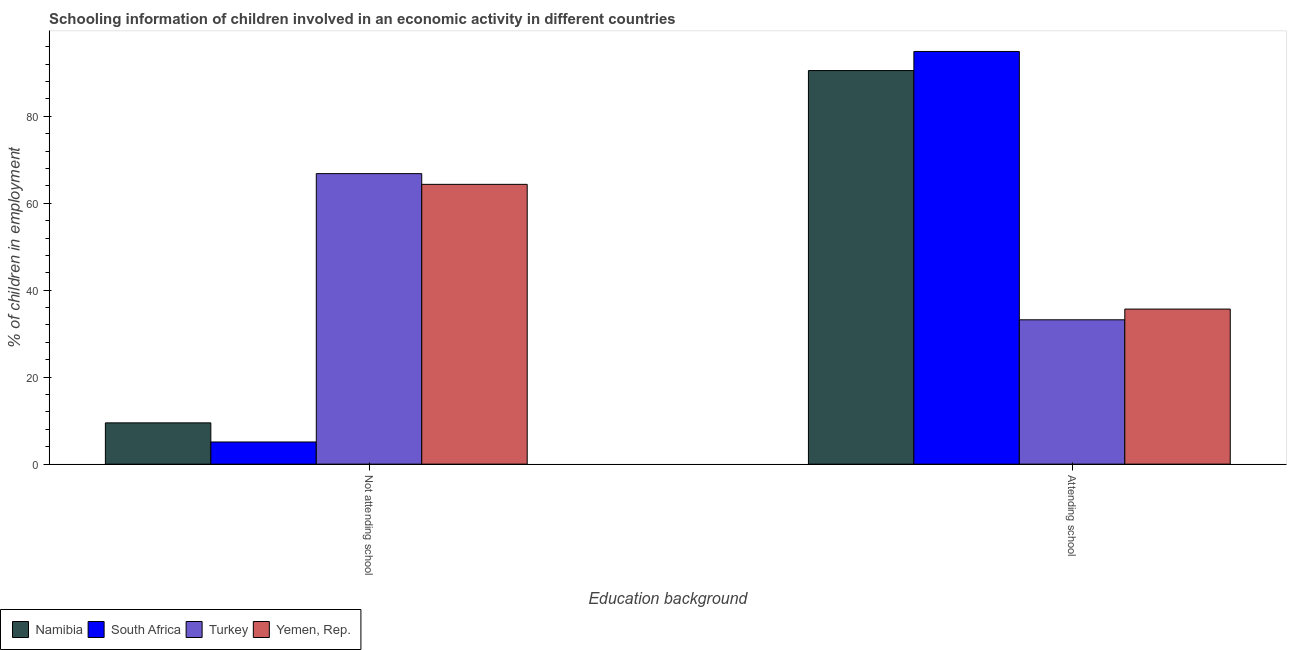How many different coloured bars are there?
Make the answer very short. 4. How many groups of bars are there?
Provide a succinct answer. 2. How many bars are there on the 1st tick from the left?
Ensure brevity in your answer.  4. What is the label of the 1st group of bars from the left?
Give a very brief answer. Not attending school. Across all countries, what is the maximum percentage of employed children who are attending school?
Keep it short and to the point. 94.9. In which country was the percentage of employed children who are attending school maximum?
Keep it short and to the point. South Africa. In which country was the percentage of employed children who are attending school minimum?
Offer a terse response. Turkey. What is the total percentage of employed children who are not attending school in the graph?
Your response must be concise. 145.74. What is the difference between the percentage of employed children who are attending school in Turkey and that in South Africa?
Keep it short and to the point. -61.71. What is the difference between the percentage of employed children who are not attending school in Yemen, Rep. and the percentage of employed children who are attending school in Namibia?
Provide a succinct answer. -26.17. What is the average percentage of employed children who are not attending school per country?
Offer a very short reply. 36.43. What is the difference between the percentage of employed children who are not attending school and percentage of employed children who are attending school in Yemen, Rep.?
Offer a terse response. 28.68. In how many countries, is the percentage of employed children who are attending school greater than 28 %?
Provide a succinct answer. 4. What is the ratio of the percentage of employed children who are attending school in Namibia to that in Yemen, Rep.?
Provide a short and direct response. 2.54. In how many countries, is the percentage of employed children who are not attending school greater than the average percentage of employed children who are not attending school taken over all countries?
Your response must be concise. 2. What does the 3rd bar from the right in Attending school represents?
Your response must be concise. South Africa. How many bars are there?
Provide a short and direct response. 8. How many countries are there in the graph?
Your answer should be compact. 4. What is the difference between two consecutive major ticks on the Y-axis?
Provide a succinct answer. 20. Are the values on the major ticks of Y-axis written in scientific E-notation?
Offer a terse response. No. Does the graph contain any zero values?
Your answer should be very brief. No. Does the graph contain grids?
Keep it short and to the point. No. How many legend labels are there?
Make the answer very short. 4. What is the title of the graph?
Offer a terse response. Schooling information of children involved in an economic activity in different countries. What is the label or title of the X-axis?
Ensure brevity in your answer.  Education background. What is the label or title of the Y-axis?
Your answer should be compact. % of children in employment. What is the % of children in employment in Namibia in Not attending school?
Make the answer very short. 9.49. What is the % of children in employment in Turkey in Not attending school?
Offer a very short reply. 66.81. What is the % of children in employment in Yemen, Rep. in Not attending school?
Your answer should be compact. 64.34. What is the % of children in employment in Namibia in Attending school?
Offer a terse response. 90.51. What is the % of children in employment of South Africa in Attending school?
Make the answer very short. 94.9. What is the % of children in employment of Turkey in Attending school?
Make the answer very short. 33.19. What is the % of children in employment in Yemen, Rep. in Attending school?
Ensure brevity in your answer.  35.66. Across all Education background, what is the maximum % of children in employment in Namibia?
Make the answer very short. 90.51. Across all Education background, what is the maximum % of children in employment in South Africa?
Provide a succinct answer. 94.9. Across all Education background, what is the maximum % of children in employment in Turkey?
Provide a short and direct response. 66.81. Across all Education background, what is the maximum % of children in employment in Yemen, Rep.?
Offer a terse response. 64.34. Across all Education background, what is the minimum % of children in employment in Namibia?
Provide a short and direct response. 9.49. Across all Education background, what is the minimum % of children in employment in South Africa?
Make the answer very short. 5.1. Across all Education background, what is the minimum % of children in employment in Turkey?
Give a very brief answer. 33.19. Across all Education background, what is the minimum % of children in employment in Yemen, Rep.?
Offer a very short reply. 35.66. What is the total % of children in employment of Namibia in the graph?
Offer a very short reply. 100. What is the total % of children in employment in Turkey in the graph?
Your response must be concise. 100. What is the difference between the % of children in employment of Namibia in Not attending school and that in Attending school?
Your response must be concise. -81.01. What is the difference between the % of children in employment of South Africa in Not attending school and that in Attending school?
Make the answer very short. -89.8. What is the difference between the % of children in employment in Turkey in Not attending school and that in Attending school?
Your answer should be compact. 33.61. What is the difference between the % of children in employment in Yemen, Rep. in Not attending school and that in Attending school?
Keep it short and to the point. 28.68. What is the difference between the % of children in employment of Namibia in Not attending school and the % of children in employment of South Africa in Attending school?
Keep it short and to the point. -85.41. What is the difference between the % of children in employment in Namibia in Not attending school and the % of children in employment in Turkey in Attending school?
Ensure brevity in your answer.  -23.7. What is the difference between the % of children in employment in Namibia in Not attending school and the % of children in employment in Yemen, Rep. in Attending school?
Provide a short and direct response. -26.17. What is the difference between the % of children in employment in South Africa in Not attending school and the % of children in employment in Turkey in Attending school?
Make the answer very short. -28.09. What is the difference between the % of children in employment in South Africa in Not attending school and the % of children in employment in Yemen, Rep. in Attending school?
Your answer should be very brief. -30.56. What is the difference between the % of children in employment in Turkey in Not attending school and the % of children in employment in Yemen, Rep. in Attending school?
Offer a very short reply. 31.15. What is the average % of children in employment in Turkey per Education background?
Keep it short and to the point. 50. What is the average % of children in employment in Yemen, Rep. per Education background?
Ensure brevity in your answer.  50. What is the difference between the % of children in employment in Namibia and % of children in employment in South Africa in Not attending school?
Your response must be concise. 4.39. What is the difference between the % of children in employment in Namibia and % of children in employment in Turkey in Not attending school?
Give a very brief answer. -57.31. What is the difference between the % of children in employment of Namibia and % of children in employment of Yemen, Rep. in Not attending school?
Your answer should be compact. -54.85. What is the difference between the % of children in employment in South Africa and % of children in employment in Turkey in Not attending school?
Your answer should be compact. -61.7. What is the difference between the % of children in employment of South Africa and % of children in employment of Yemen, Rep. in Not attending school?
Provide a short and direct response. -59.24. What is the difference between the % of children in employment in Turkey and % of children in employment in Yemen, Rep. in Not attending school?
Keep it short and to the point. 2.46. What is the difference between the % of children in employment in Namibia and % of children in employment in South Africa in Attending school?
Keep it short and to the point. -4.39. What is the difference between the % of children in employment in Namibia and % of children in employment in Turkey in Attending school?
Your answer should be compact. 57.31. What is the difference between the % of children in employment of Namibia and % of children in employment of Yemen, Rep. in Attending school?
Your answer should be compact. 54.85. What is the difference between the % of children in employment in South Africa and % of children in employment in Turkey in Attending school?
Provide a short and direct response. 61.7. What is the difference between the % of children in employment of South Africa and % of children in employment of Yemen, Rep. in Attending school?
Ensure brevity in your answer.  59.24. What is the difference between the % of children in employment in Turkey and % of children in employment in Yemen, Rep. in Attending school?
Give a very brief answer. -2.46. What is the ratio of the % of children in employment of Namibia in Not attending school to that in Attending school?
Ensure brevity in your answer.  0.1. What is the ratio of the % of children in employment in South Africa in Not attending school to that in Attending school?
Offer a terse response. 0.05. What is the ratio of the % of children in employment of Turkey in Not attending school to that in Attending school?
Ensure brevity in your answer.  2.01. What is the ratio of the % of children in employment in Yemen, Rep. in Not attending school to that in Attending school?
Your response must be concise. 1.8. What is the difference between the highest and the second highest % of children in employment in Namibia?
Your answer should be very brief. 81.01. What is the difference between the highest and the second highest % of children in employment in South Africa?
Provide a succinct answer. 89.8. What is the difference between the highest and the second highest % of children in employment in Turkey?
Your answer should be compact. 33.61. What is the difference between the highest and the second highest % of children in employment of Yemen, Rep.?
Your response must be concise. 28.68. What is the difference between the highest and the lowest % of children in employment of Namibia?
Offer a terse response. 81.01. What is the difference between the highest and the lowest % of children in employment in South Africa?
Your answer should be compact. 89.8. What is the difference between the highest and the lowest % of children in employment of Turkey?
Provide a short and direct response. 33.61. What is the difference between the highest and the lowest % of children in employment of Yemen, Rep.?
Keep it short and to the point. 28.68. 